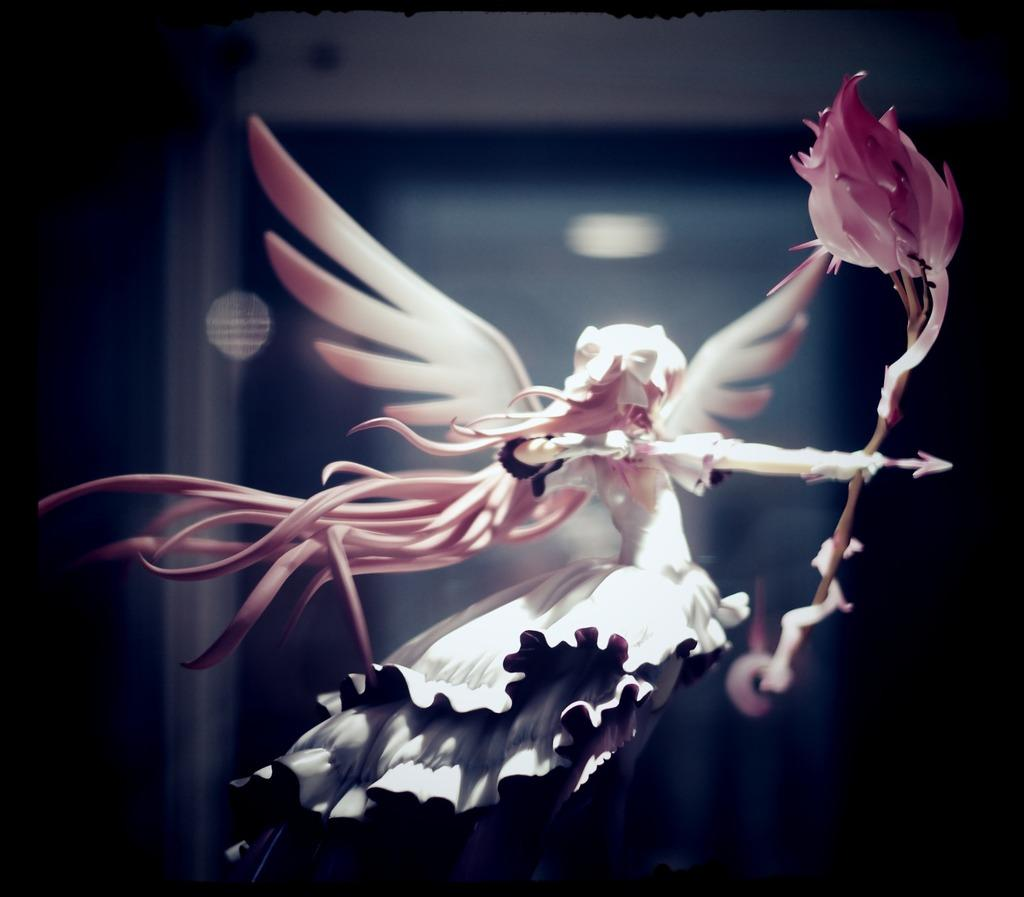What is the main subject of the image? There is a small statue in the image. Can you describe the statue? The statue appears to be of an angel. What is the angel holding in the image? The angel is holding an arrow and a bow. What can be seen in the background of the image? There is a light in the background of the image. How would you describe the background's appearance? The background of the image is blurry. What type of flower is growing in the bucket next to the statue? There is no flower or bucket present in the image; it only features a small statue of an angel holding an arrow and a bow, with a blurry background and a light. 